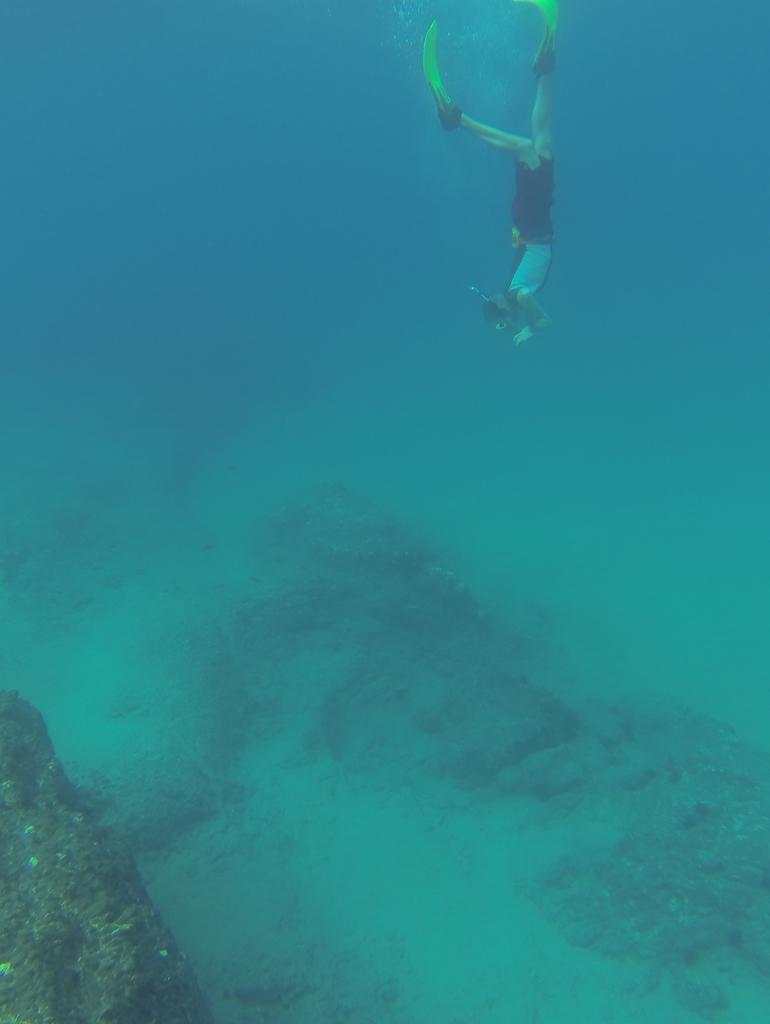Please provide a concise description of this image. In this image there is a person diving in water. He is wearing goggles. Bottom of the image there is land having few rocks. Background there is water. 